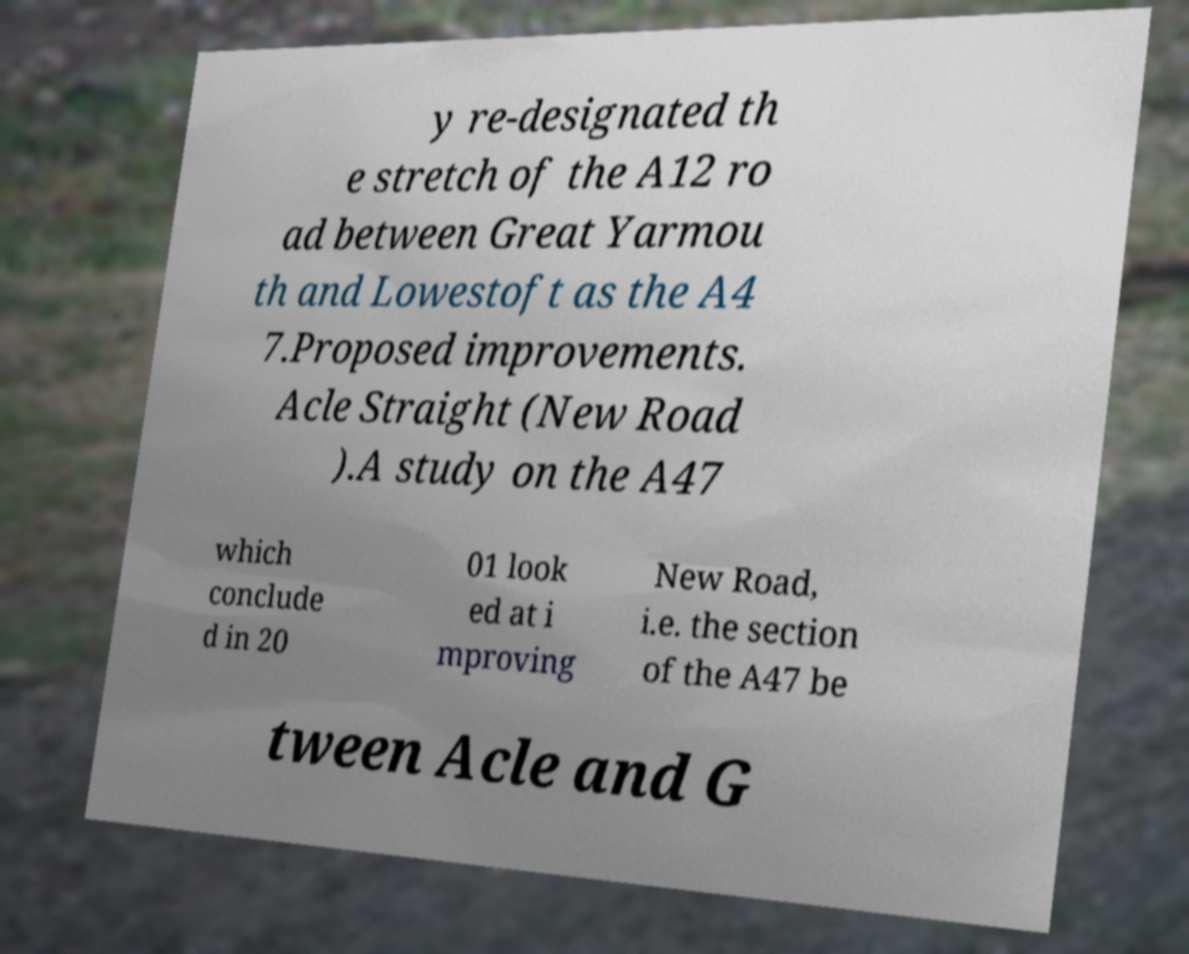I need the written content from this picture converted into text. Can you do that? y re-designated th e stretch of the A12 ro ad between Great Yarmou th and Lowestoft as the A4 7.Proposed improvements. Acle Straight (New Road ).A study on the A47 which conclude d in 20 01 look ed at i mproving New Road, i.e. the section of the A47 be tween Acle and G 